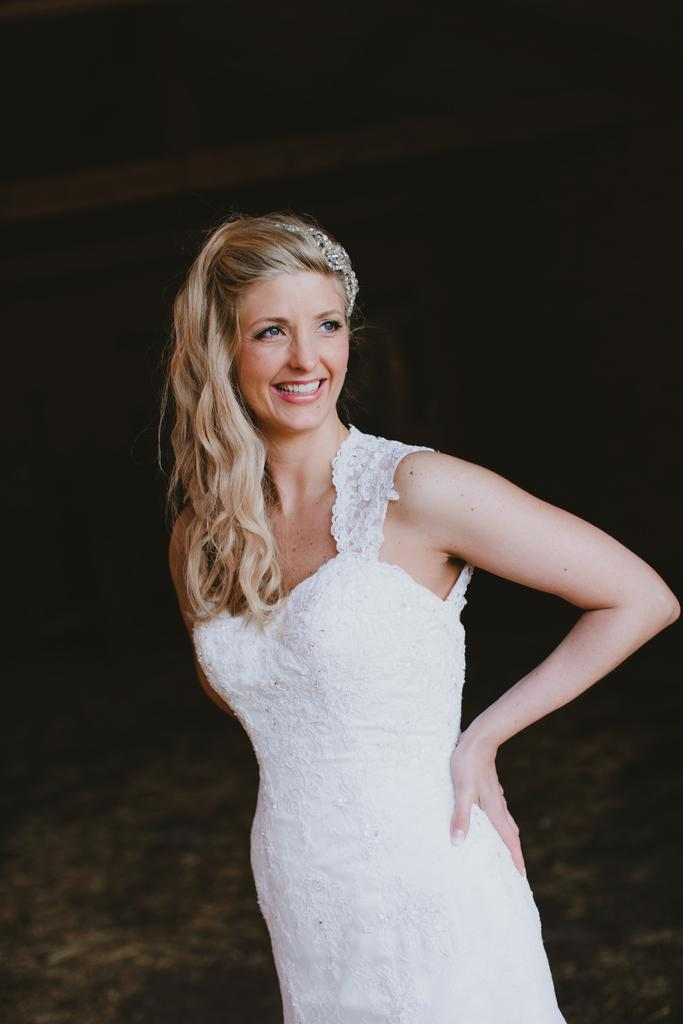What is the main subject of the image? The main subject of the image is a woman. What is the woman doing in the image? The woman is standing in the image. What is the woman's facial expression in the image? The woman is smiling in the image. What is the woman wearing in the image? The woman is wearing a white dress in the image. What is the color of the background in the image? The background of the image is dark. What type of country can be seen in the background of the image? There is no country visible in the background of the image; it is a dark background. How many rabbits are visible in the image? There are no rabbits present in the image. What book is the woman holding in the image? There is no book visible in the image. 